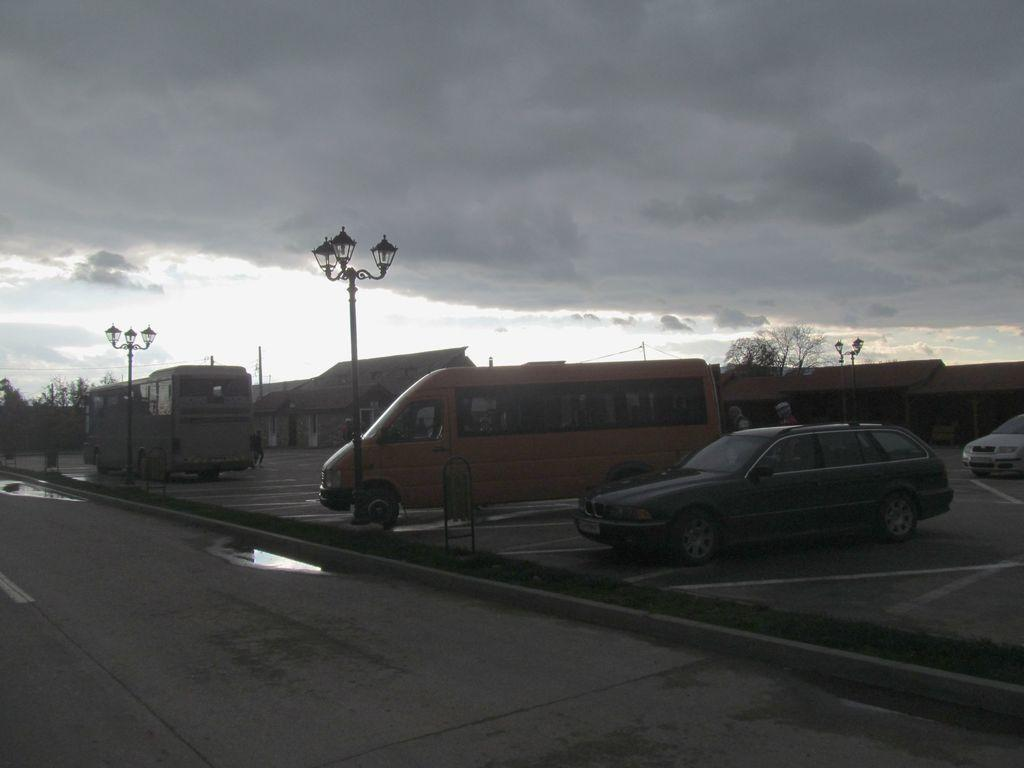What is the main feature of the image? There is a road in the image. What is happening on the road? There is water on the road, and there are vehicles present. What structures are visible along the road? There are street light poles in the image. What can be seen in the background of the image? There are buildings, poles, trees, and the sky visible in the background. What type of meal is being prepared in the basin in the image? There is no basin or meal preparation present in the image. What type of competition is taking place in the image? There is no competition depicted in the image. 